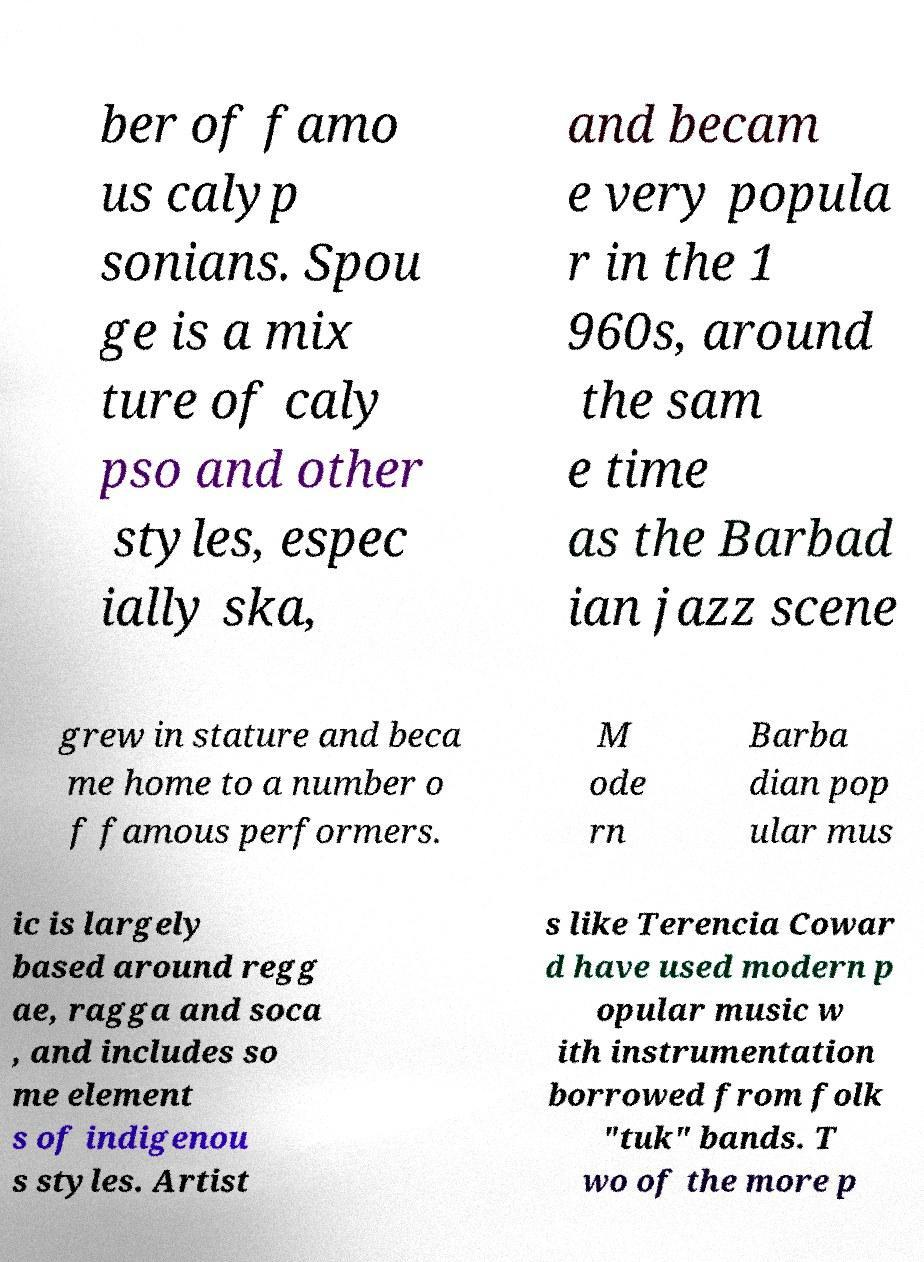For documentation purposes, I need the text within this image transcribed. Could you provide that? ber of famo us calyp sonians. Spou ge is a mix ture of caly pso and other styles, espec ially ska, and becam e very popula r in the 1 960s, around the sam e time as the Barbad ian jazz scene grew in stature and beca me home to a number o f famous performers. M ode rn Barba dian pop ular mus ic is largely based around regg ae, ragga and soca , and includes so me element s of indigenou s styles. Artist s like Terencia Cowar d have used modern p opular music w ith instrumentation borrowed from folk "tuk" bands. T wo of the more p 